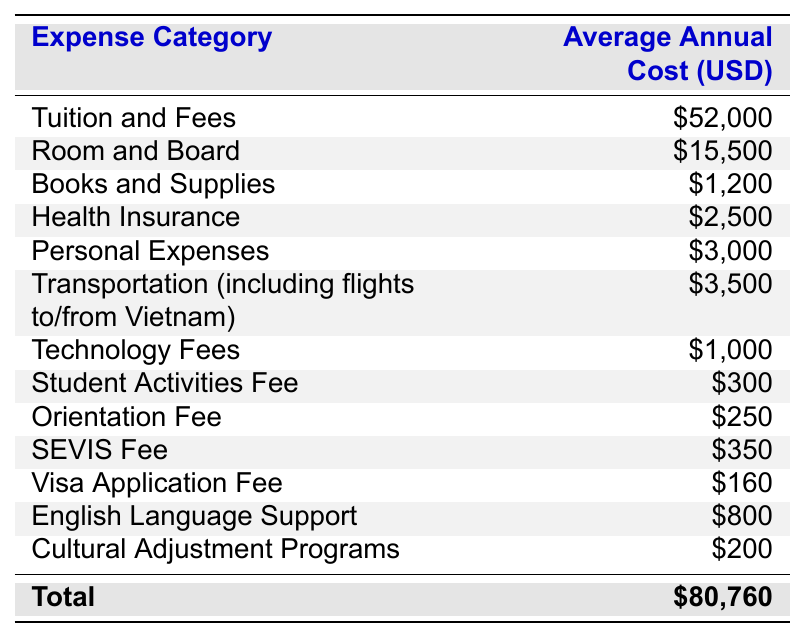What is the total average annual cost for an international student? The table lists individual expenses and the total average annual cost is shown at the bottom as $80,760.
Answer: $80,760 How much does tuition and fees cost annually? The annual cost for tuition and fees is displayed directly in the table next to that expense, which is $52,000.
Answer: $52,000 Is the cost of books and supplies less than the cost of health insurance? The cost of books and supplies is $1,200 and the cost of health insurance is $2,500. Since $1,200 is less than $2,500, the answer is yes.
Answer: Yes What is the combined cost of personal expenses and transportation? Personal expenses are $3,000, and transportation is $3,500. Adding these two amounts gives $3,000 + $3,500 = $6,500.
Answer: $6,500 What is the average cost for health-related expenses (health insurance and English language support)? Health insurance costs $2,500 and English language support costs $800. First, sum these amounts: $2,500 + $800 = $3,300. Then, divide by 2 to find the average: $3,300 / 2 = $1,650.
Answer: $1,650 How much more does tuition and fees cost than the total of all other listed expenses? The total cost from the table is $80,760, and tuition and fees are $52,000. To find the total of the other expenses subtract tuition from total: $80,760 - $52,000 = $28,760. The difference is $52,000 - $28,760 = $23,240.
Answer: $23,240 Which expense has the lowest cost? The expense categories are compared from the lowest value. Student Activities Fee is $300, Orientation Fee is $250, and Cultural Adjustment Programs is $200. Among these, Cultural Adjustment Programs has the lowest cost at $200.
Answer: $200 What percentage of the total cost is spent on room and board? Room and board costs $15,500 and the total is $80,760. The percentage is calculated as ($15,500 / $80,760) * 100. This gives approximately 19.19%, which rounds to 19.2%.
Answer: 19.2% How much do the fees for SEVIS and visa application add up to? The SEVIS Fee is $350 and the Visa Application Fee is $160. Adding these amounts gives $350 + $160 = $510.
Answer: $510 If a student were to budget equally across the board for all expenses, what would be the budget for each category? There are 13 expense categories listed. To find the budget per category, divide the total $80,760 by 13: $80,760 / 13 is approximately $6,221.54.
Answer: $6,221.54 